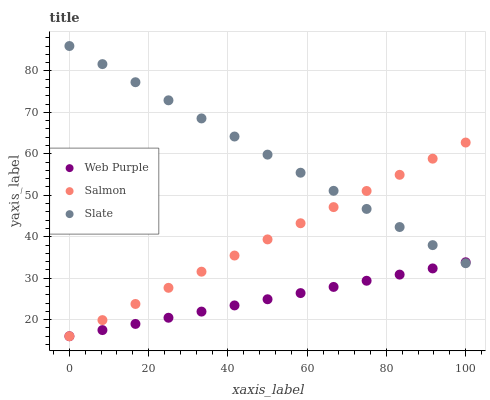Does Web Purple have the minimum area under the curve?
Answer yes or no. Yes. Does Slate have the maximum area under the curve?
Answer yes or no. Yes. Does Salmon have the minimum area under the curve?
Answer yes or no. No. Does Salmon have the maximum area under the curve?
Answer yes or no. No. Is Web Purple the smoothest?
Answer yes or no. Yes. Is Slate the roughest?
Answer yes or no. Yes. Is Salmon the smoothest?
Answer yes or no. No. Is Salmon the roughest?
Answer yes or no. No. Does Web Purple have the lowest value?
Answer yes or no. Yes. Does Slate have the lowest value?
Answer yes or no. No. Does Slate have the highest value?
Answer yes or no. Yes. Does Salmon have the highest value?
Answer yes or no. No. Does Web Purple intersect Salmon?
Answer yes or no. Yes. Is Web Purple less than Salmon?
Answer yes or no. No. Is Web Purple greater than Salmon?
Answer yes or no. No. 